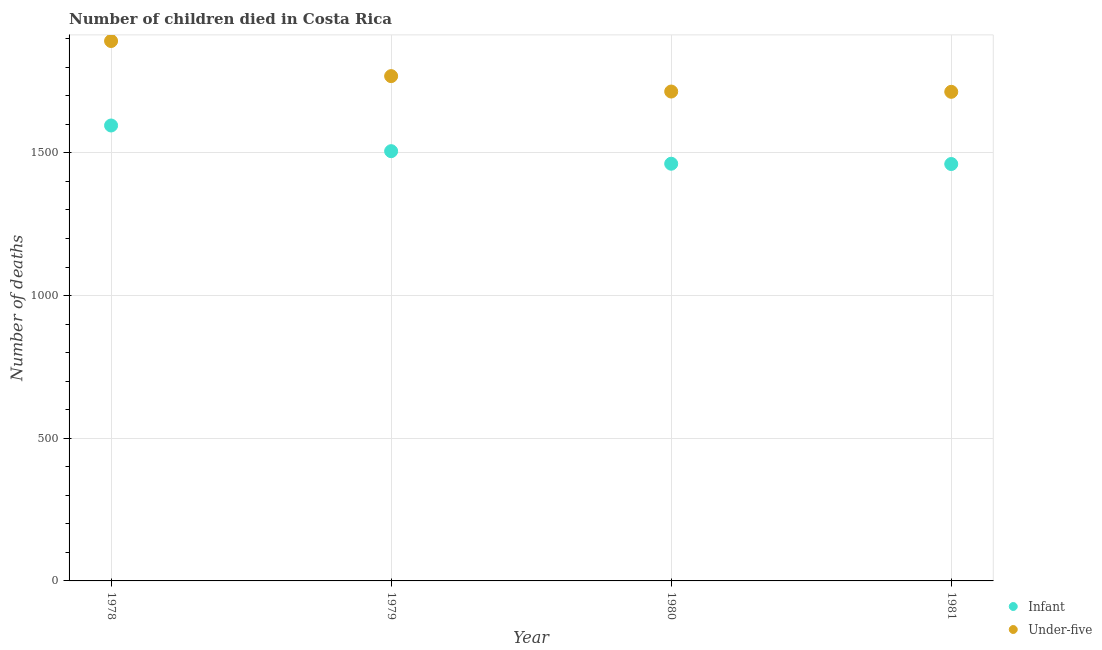Is the number of dotlines equal to the number of legend labels?
Make the answer very short. Yes. What is the number of under-five deaths in 1978?
Your response must be concise. 1892. Across all years, what is the maximum number of under-five deaths?
Your answer should be compact. 1892. Across all years, what is the minimum number of under-five deaths?
Your answer should be compact. 1714. In which year was the number of under-five deaths maximum?
Offer a very short reply. 1978. What is the total number of infant deaths in the graph?
Offer a very short reply. 6025. What is the difference between the number of infant deaths in 1978 and that in 1980?
Make the answer very short. 134. What is the difference between the number of under-five deaths in 1979 and the number of infant deaths in 1978?
Your answer should be very brief. 173. What is the average number of infant deaths per year?
Provide a short and direct response. 1506.25. In the year 1981, what is the difference between the number of under-five deaths and number of infant deaths?
Ensure brevity in your answer.  253. What is the ratio of the number of infant deaths in 1978 to that in 1981?
Your response must be concise. 1.09. Is the number of infant deaths in 1978 less than that in 1980?
Give a very brief answer. No. What is the difference between the highest and the second highest number of under-five deaths?
Provide a succinct answer. 123. What is the difference between the highest and the lowest number of under-five deaths?
Offer a very short reply. 178. How many dotlines are there?
Make the answer very short. 2. Are the values on the major ticks of Y-axis written in scientific E-notation?
Provide a short and direct response. No. Does the graph contain grids?
Offer a terse response. Yes. Where does the legend appear in the graph?
Offer a very short reply. Bottom right. What is the title of the graph?
Your response must be concise. Number of children died in Costa Rica. Does "Nonresident" appear as one of the legend labels in the graph?
Your answer should be very brief. No. What is the label or title of the X-axis?
Ensure brevity in your answer.  Year. What is the label or title of the Y-axis?
Ensure brevity in your answer.  Number of deaths. What is the Number of deaths of Infant in 1978?
Your response must be concise. 1596. What is the Number of deaths of Under-five in 1978?
Your response must be concise. 1892. What is the Number of deaths of Infant in 1979?
Keep it short and to the point. 1506. What is the Number of deaths of Under-five in 1979?
Ensure brevity in your answer.  1769. What is the Number of deaths in Infant in 1980?
Provide a short and direct response. 1462. What is the Number of deaths of Under-five in 1980?
Provide a short and direct response. 1715. What is the Number of deaths of Infant in 1981?
Provide a short and direct response. 1461. What is the Number of deaths of Under-five in 1981?
Provide a short and direct response. 1714. Across all years, what is the maximum Number of deaths of Infant?
Make the answer very short. 1596. Across all years, what is the maximum Number of deaths in Under-five?
Offer a very short reply. 1892. Across all years, what is the minimum Number of deaths of Infant?
Ensure brevity in your answer.  1461. Across all years, what is the minimum Number of deaths of Under-five?
Ensure brevity in your answer.  1714. What is the total Number of deaths in Infant in the graph?
Make the answer very short. 6025. What is the total Number of deaths of Under-five in the graph?
Keep it short and to the point. 7090. What is the difference between the Number of deaths of Under-five in 1978 and that in 1979?
Your response must be concise. 123. What is the difference between the Number of deaths of Infant in 1978 and that in 1980?
Give a very brief answer. 134. What is the difference between the Number of deaths in Under-five in 1978 and that in 1980?
Provide a short and direct response. 177. What is the difference between the Number of deaths in Infant in 1978 and that in 1981?
Your response must be concise. 135. What is the difference between the Number of deaths in Under-five in 1978 and that in 1981?
Give a very brief answer. 178. What is the difference between the Number of deaths of Infant in 1979 and that in 1980?
Keep it short and to the point. 44. What is the difference between the Number of deaths of Infant in 1979 and that in 1981?
Provide a succinct answer. 45. What is the difference between the Number of deaths of Under-five in 1979 and that in 1981?
Offer a very short reply. 55. What is the difference between the Number of deaths in Under-five in 1980 and that in 1981?
Provide a succinct answer. 1. What is the difference between the Number of deaths in Infant in 1978 and the Number of deaths in Under-five in 1979?
Your answer should be very brief. -173. What is the difference between the Number of deaths of Infant in 1978 and the Number of deaths of Under-five in 1980?
Make the answer very short. -119. What is the difference between the Number of deaths of Infant in 1978 and the Number of deaths of Under-five in 1981?
Keep it short and to the point. -118. What is the difference between the Number of deaths in Infant in 1979 and the Number of deaths in Under-five in 1980?
Provide a succinct answer. -209. What is the difference between the Number of deaths in Infant in 1979 and the Number of deaths in Under-five in 1981?
Your answer should be very brief. -208. What is the difference between the Number of deaths in Infant in 1980 and the Number of deaths in Under-five in 1981?
Offer a very short reply. -252. What is the average Number of deaths in Infant per year?
Provide a short and direct response. 1506.25. What is the average Number of deaths of Under-five per year?
Offer a terse response. 1772.5. In the year 1978, what is the difference between the Number of deaths of Infant and Number of deaths of Under-five?
Offer a very short reply. -296. In the year 1979, what is the difference between the Number of deaths of Infant and Number of deaths of Under-five?
Make the answer very short. -263. In the year 1980, what is the difference between the Number of deaths in Infant and Number of deaths in Under-five?
Ensure brevity in your answer.  -253. In the year 1981, what is the difference between the Number of deaths in Infant and Number of deaths in Under-five?
Keep it short and to the point. -253. What is the ratio of the Number of deaths in Infant in 1978 to that in 1979?
Provide a short and direct response. 1.06. What is the ratio of the Number of deaths of Under-five in 1978 to that in 1979?
Ensure brevity in your answer.  1.07. What is the ratio of the Number of deaths in Infant in 1978 to that in 1980?
Make the answer very short. 1.09. What is the ratio of the Number of deaths in Under-five in 1978 to that in 1980?
Give a very brief answer. 1.1. What is the ratio of the Number of deaths of Infant in 1978 to that in 1981?
Your response must be concise. 1.09. What is the ratio of the Number of deaths of Under-five in 1978 to that in 1981?
Provide a short and direct response. 1.1. What is the ratio of the Number of deaths in Infant in 1979 to that in 1980?
Your answer should be very brief. 1.03. What is the ratio of the Number of deaths of Under-five in 1979 to that in 1980?
Your answer should be compact. 1.03. What is the ratio of the Number of deaths of Infant in 1979 to that in 1981?
Your answer should be compact. 1.03. What is the ratio of the Number of deaths in Under-five in 1979 to that in 1981?
Provide a short and direct response. 1.03. What is the ratio of the Number of deaths of Infant in 1980 to that in 1981?
Offer a very short reply. 1. What is the ratio of the Number of deaths of Under-five in 1980 to that in 1981?
Give a very brief answer. 1. What is the difference between the highest and the second highest Number of deaths in Infant?
Provide a succinct answer. 90. What is the difference between the highest and the second highest Number of deaths in Under-five?
Keep it short and to the point. 123. What is the difference between the highest and the lowest Number of deaths in Infant?
Give a very brief answer. 135. What is the difference between the highest and the lowest Number of deaths in Under-five?
Make the answer very short. 178. 